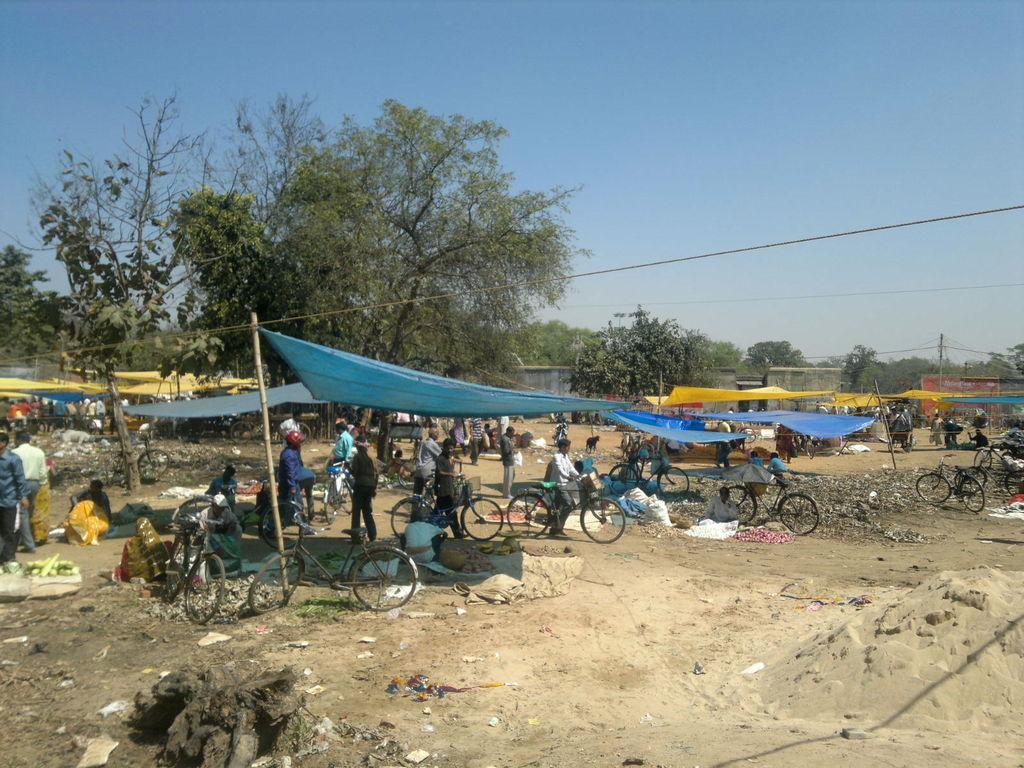Please provide a concise description of this image. There are few people sitting and standing. These are the bicycles. I can see the sheets hanging. These are the trees. There are few people holding bicycles and walking. This looks like a current pole. I think this is a market. 